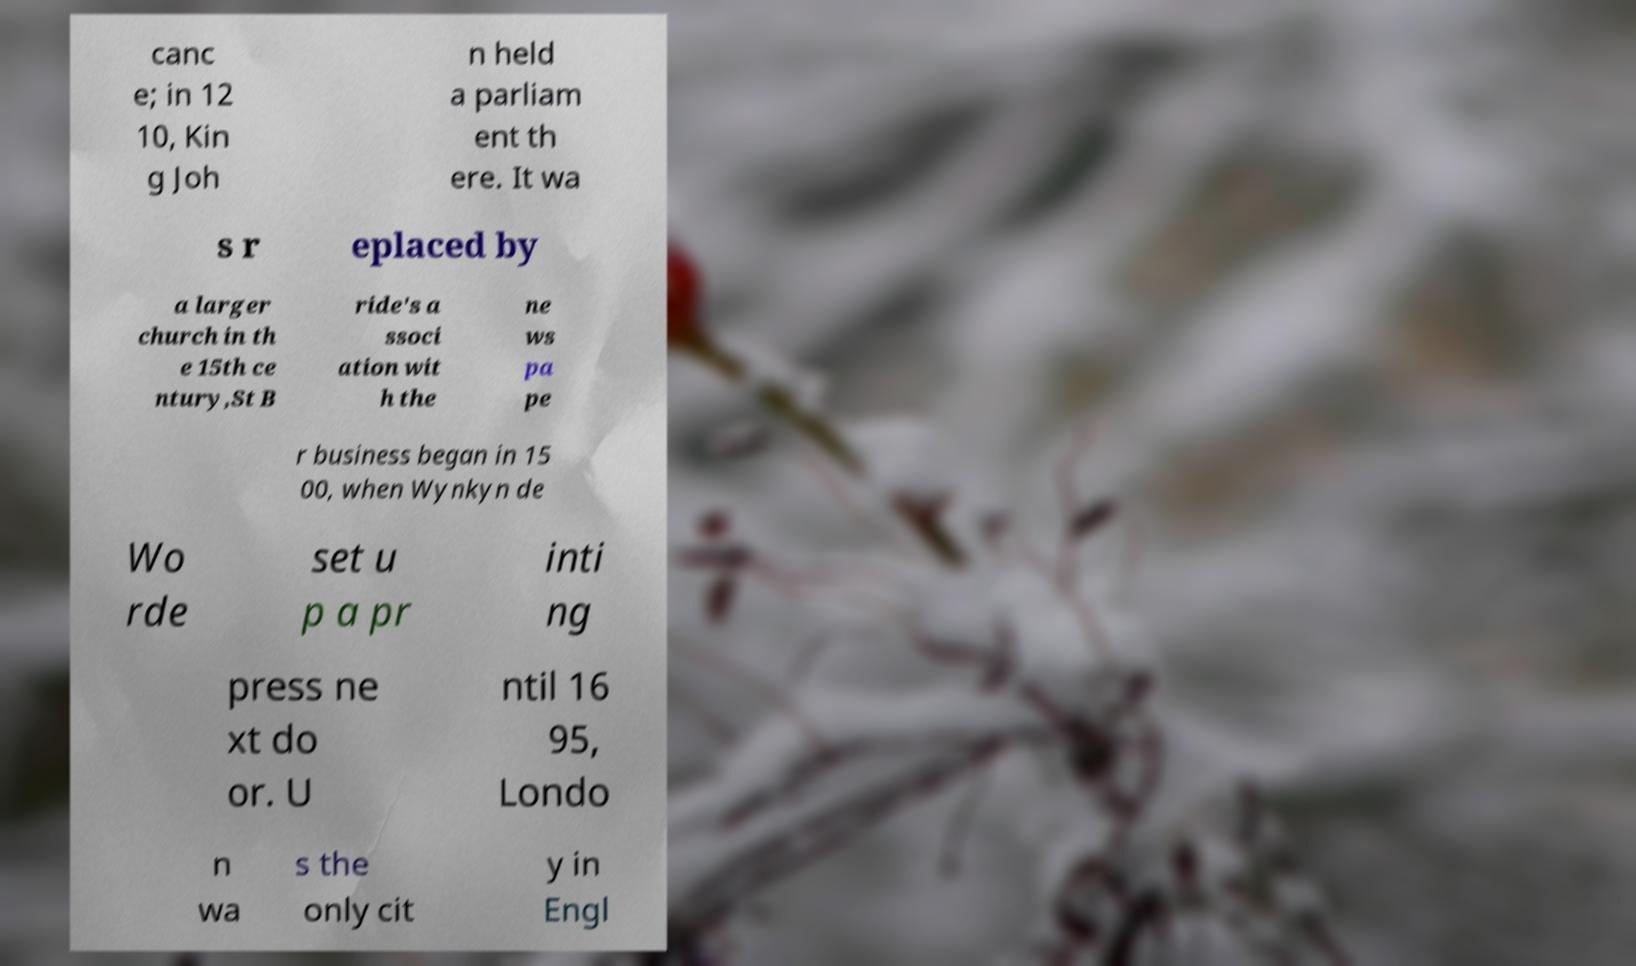There's text embedded in this image that I need extracted. Can you transcribe it verbatim? canc e; in 12 10, Kin g Joh n held a parliam ent th ere. It wa s r eplaced by a larger church in th e 15th ce ntury,St B ride's a ssoci ation wit h the ne ws pa pe r business began in 15 00, when Wynkyn de Wo rde set u p a pr inti ng press ne xt do or. U ntil 16 95, Londo n wa s the only cit y in Engl 